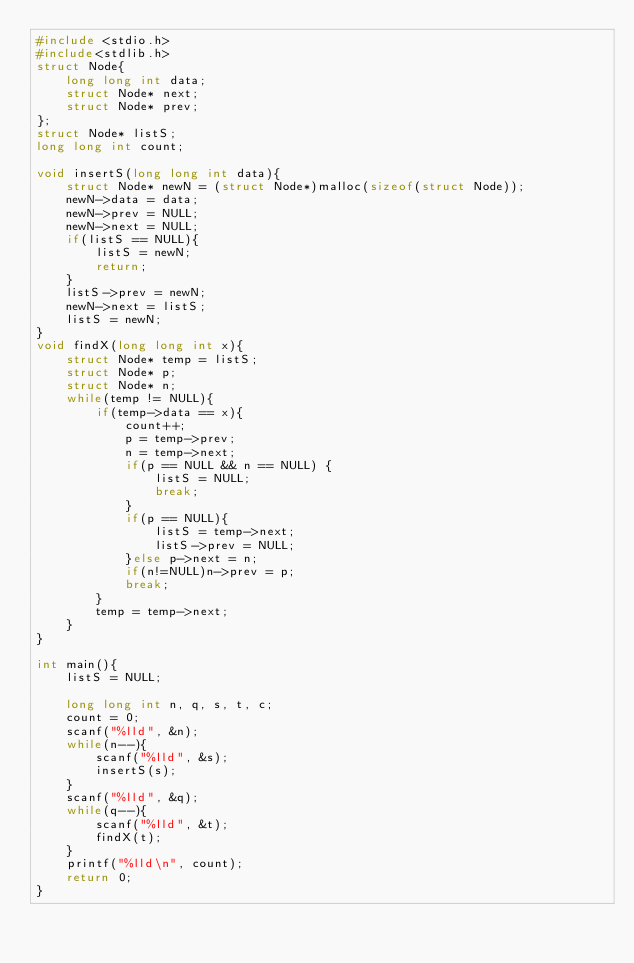<code> <loc_0><loc_0><loc_500><loc_500><_C_>#include <stdio.h>
#include<stdlib.h>
struct Node{
    long long int data;
    struct Node* next;
    struct Node* prev;
};
struct Node* listS;
long long int count;

void insertS(long long int data){
    struct Node* newN = (struct Node*)malloc(sizeof(struct Node));
    newN->data = data;
    newN->prev = NULL;
    newN->next = NULL;
    if(listS == NULL){
        listS = newN;
        return;
    }
    listS->prev = newN;
    newN->next = listS;
    listS = newN;
}
void findX(long long int x){
    struct Node* temp = listS;
    struct Node* p;
    struct Node* n;
    while(temp != NULL){
        if(temp->data == x){
            count++;
            p = temp->prev;
            n = temp->next;
            if(p == NULL && n == NULL) {
                listS = NULL;
                break;
            }
            if(p == NULL){
                listS = temp->next;
                listS->prev = NULL;
            }else p->next = n;
            if(n!=NULL)n->prev = p;
            break;
        }
        temp = temp->next;
    }
}

int main(){
    listS = NULL;

    long long int n, q, s, t, c;
    count = 0;
    scanf("%lld", &n);
    while(n--){
        scanf("%lld", &s);
        insertS(s);
    }
    scanf("%lld", &q);
    while(q--){
        scanf("%lld", &t);
        findX(t);
    }
    printf("%lld\n", count);
    return 0;
}

</code> 